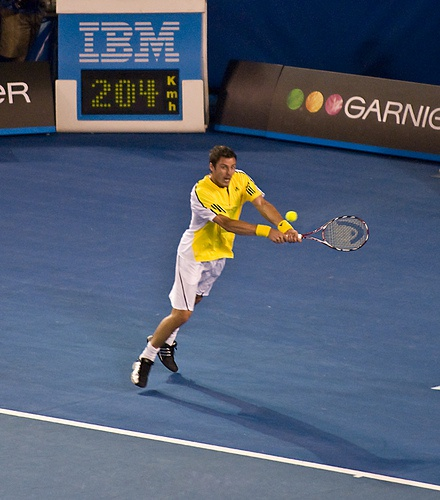Describe the objects in this image and their specific colors. I can see people in black, lightgray, gold, and olive tones, tennis racket in black, gray, and darkblue tones, and sports ball in black, gold, khaki, and olive tones in this image. 